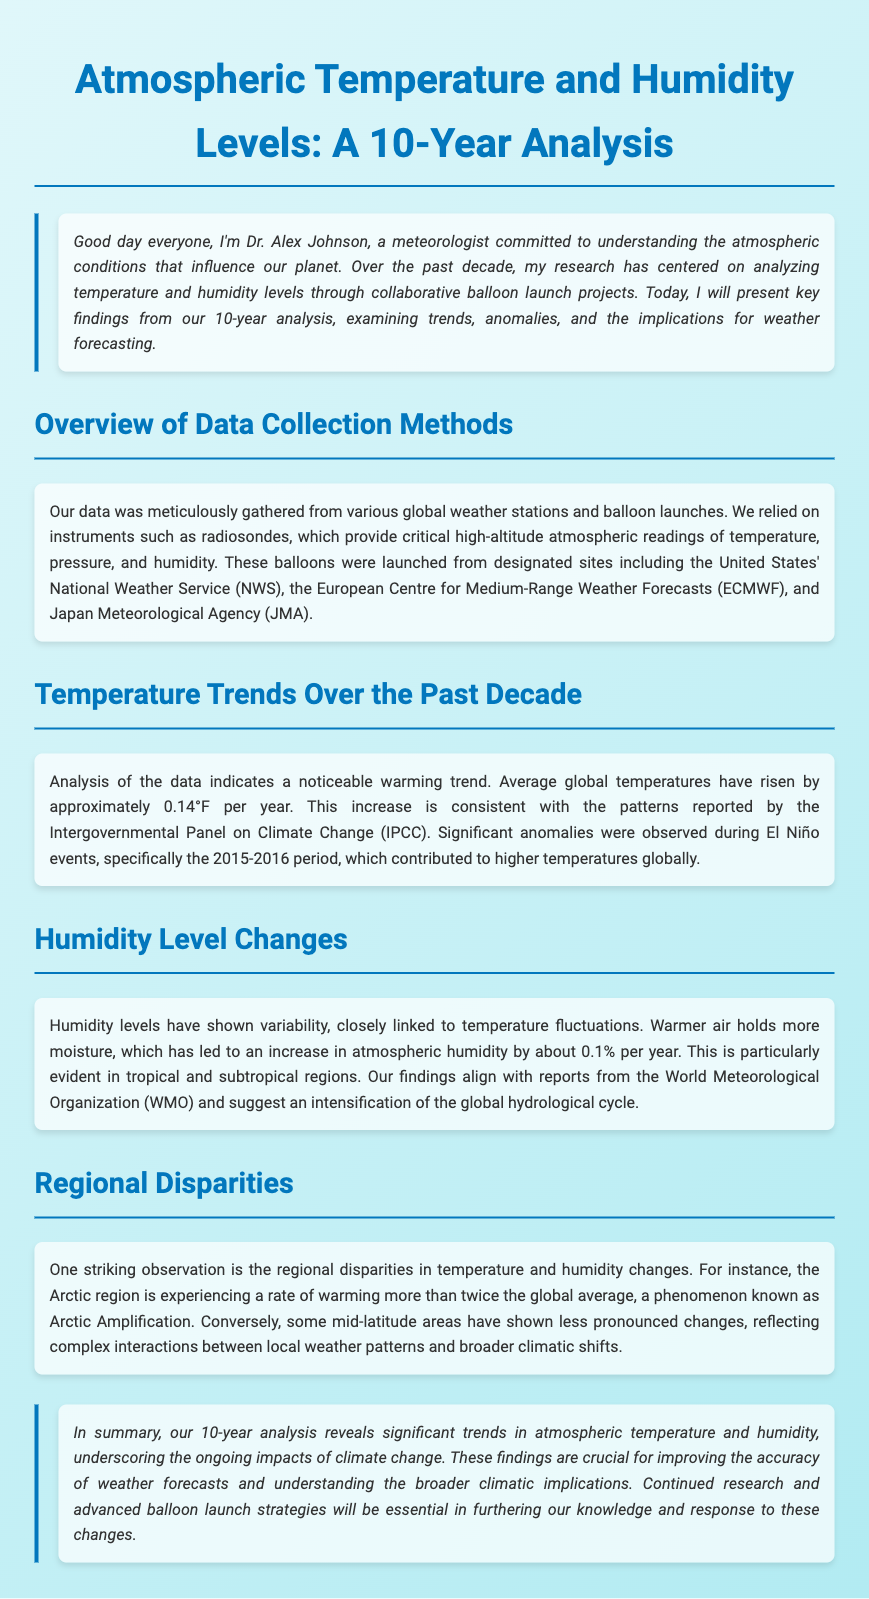What is the title of the analysis? The title can be found in the header of the document, which states the purpose of the research conducted.
Answer: Atmospheric Temperature and Humidity Levels: A 10-Year Analysis Who is the presenter of the analysis? The presenter's name is mentioned in the introductory section, providing insight into their background.
Answer: Dr. Alex Johnson What instrument was primarily used for data collection? The document specifies the key instrument used in gathering atmospheric data over the years.
Answer: Radiosondes By how much have average global temperatures risen per year? The document details the average increase in global temperatures as part of the findings.
Answer: Approximately 0.14°F What percentage increase in atmospheric humidity is reported annually? The document discusses the annual change in humidity levels in relation to temperature.
Answer: About 0.1% Which region is experiencing warming at more than twice the global average? This information about regional climate change is highlighted in the section discussing disparities.
Answer: Arctic region What major climatic events influenced temperature anomalies noted in the analysis? The analysis mentions specific events that significantly impacted global temperatures.
Answer: El Niño events Which organization reported on the alignment of findings concerning humidity levels? The document references an organization that supports the findings on humidity and climate.
Answer: World Meteorological Organization What is the key implication of the findings for weather forecasting? The conclusion emphasizes the significance of the study's findings in relation to practical applications in meteorology.
Answer: Improving the accuracy of weather forecasts 